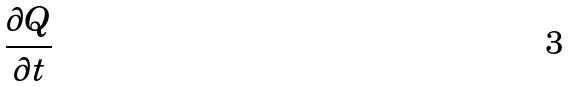Convert formula to latex. <formula><loc_0><loc_0><loc_500><loc_500>\frac { \partial Q } { \partial t }</formula> 